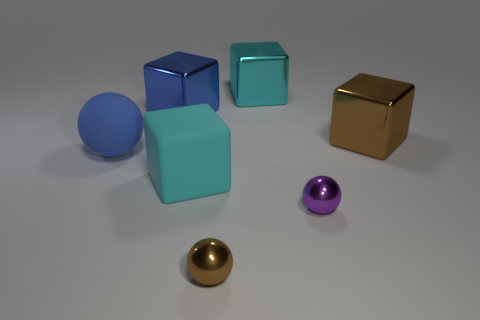How many big things are left of the large matte cube and behind the blue rubber ball? Assuming we define 'big things' as objects similar in size to the large matte cube, there is one large, golden cube to the left of the large matte cube and behind the blue rubber ball. 